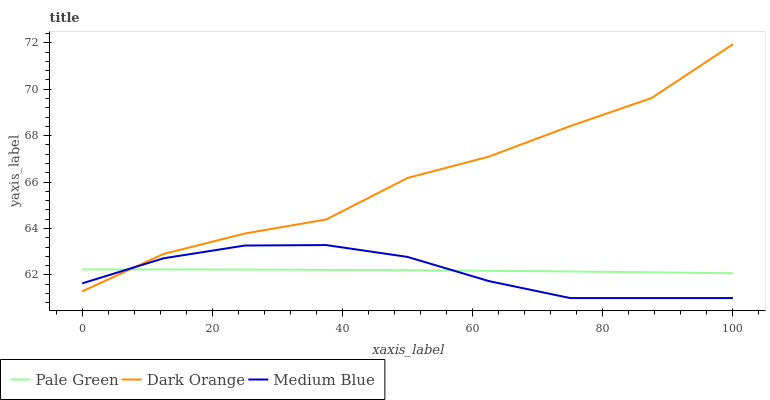Does Medium Blue have the minimum area under the curve?
Answer yes or no. Yes. Does Dark Orange have the maximum area under the curve?
Answer yes or no. Yes. Does Pale Green have the minimum area under the curve?
Answer yes or no. No. Does Pale Green have the maximum area under the curve?
Answer yes or no. No. Is Pale Green the smoothest?
Answer yes or no. Yes. Is Dark Orange the roughest?
Answer yes or no. Yes. Is Medium Blue the smoothest?
Answer yes or no. No. Is Medium Blue the roughest?
Answer yes or no. No. Does Medium Blue have the lowest value?
Answer yes or no. Yes. Does Pale Green have the lowest value?
Answer yes or no. No. Does Dark Orange have the highest value?
Answer yes or no. Yes. Does Medium Blue have the highest value?
Answer yes or no. No. Does Dark Orange intersect Medium Blue?
Answer yes or no. Yes. Is Dark Orange less than Medium Blue?
Answer yes or no. No. Is Dark Orange greater than Medium Blue?
Answer yes or no. No. 